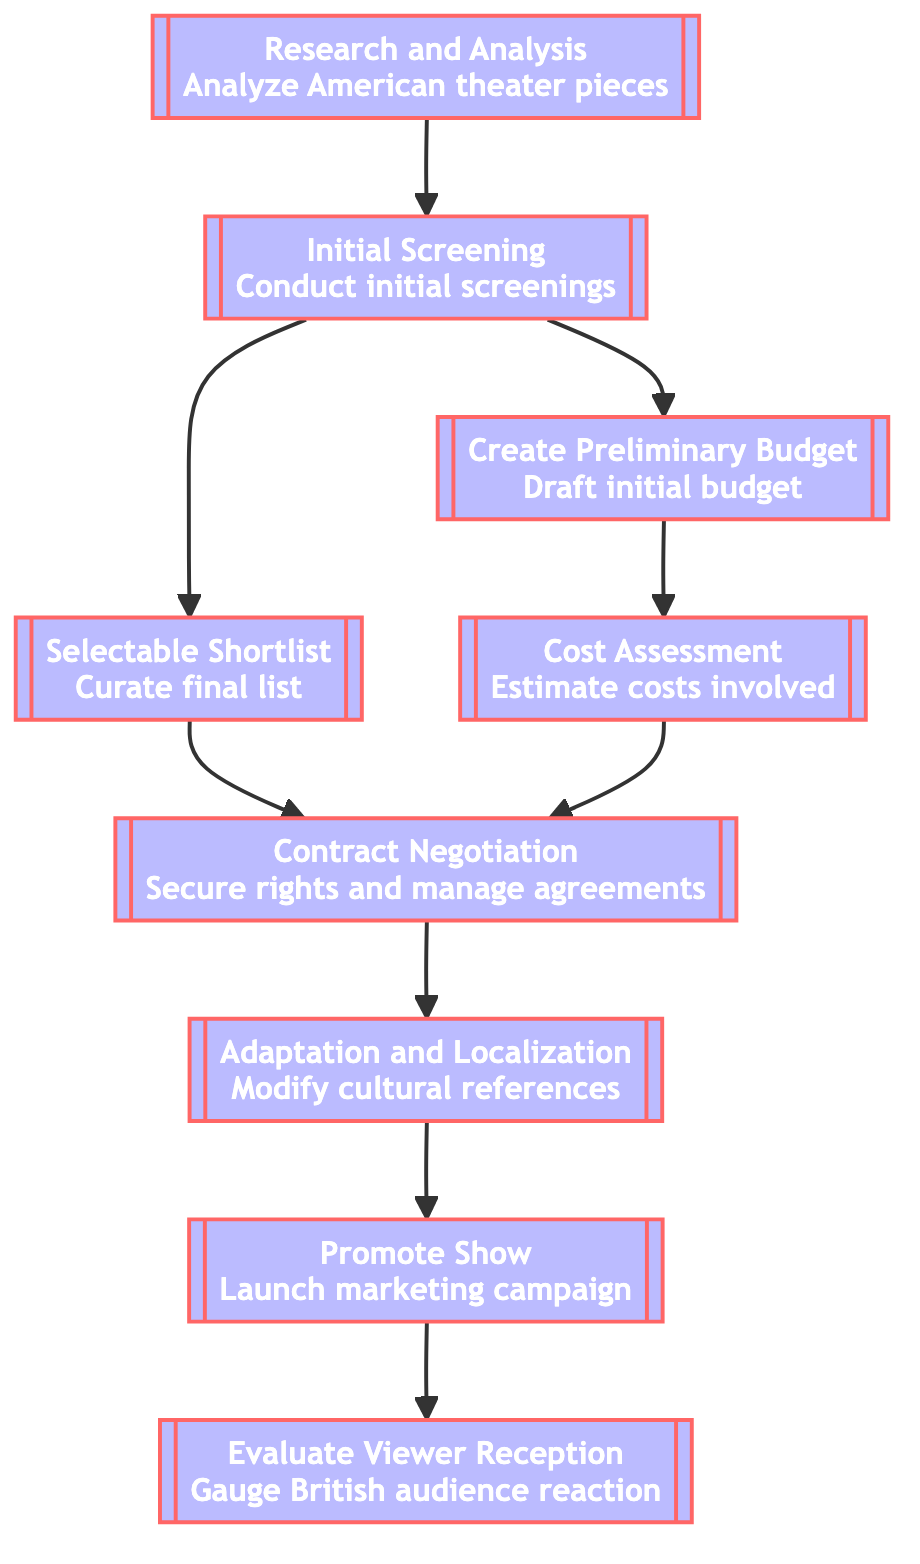What is the starting point of the flowchart? The first node in the flowchart is "Research and Analysis." It does not depend on any previous nodes, making it the starting point of the flow.
Answer: Research and Analysis How many nodes are present in the diagram? The diagram contains a total of 9 nodes that represent different stages in the selection process. Each step is a distinct node contributing to the overall process.
Answer: 9 Which node follows "Initial Screening"? The nodes that follow "Initial Screening" are "Selectable Shortlist" and "Create Preliminary Budget." Both branches lead to subsequent stages in the process, but only one node directly follows it.
Answer: Selectable Shortlist, Create Preliminary Budget What is the final step in the process? The last node in the flowchart is "Evaluate Viewer Reception," which is the final step of the selection process after promotion and adaptation activities have been completed.
Answer: Evaluate Viewer Reception Which nodes depend on "Contract Negotiation"? The nodes that depend on "Contract Negotiation" are "Adaptation and Localization." This means that adaptation tasks can only occur after contracts are negotiated.
Answer: Adaptation and Localization What happens after "Promote Show"? After "Promote Show," the next step is "Evaluate Viewer Reception," which evaluates how the British audience received the show after promotion.
Answer: Evaluate Viewer Reception Which node has the most dependencies? The node "Contract Negotiation" has the most dependencies, requiring both "Selectable Shortlist" and "Cost Assessment" to be completed beforehand.
Answer: Contract Negotiation What is the purpose of "Cost Assessment"? "Cost Assessment" aims to estimate the total costs involved in producing the show, including rights acquisition, adaptations, and marketing expenses.
Answer: Estimate costs involved How do "Selectable Shortlist" and "Cost Assessment" contribute to "Contract Negotiation"? Both "Selectable Shortlist" and "Cost Assessment" lead into "Contract Negotiation," indicating that a curated list of pieces as well as cost estimates are necessary before securing rights and managing agreements.
Answer: Selectable Shortlist, Cost Assessment 